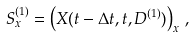Convert formula to latex. <formula><loc_0><loc_0><loc_500><loc_500>S ^ { ( 1 ) } _ { x } = \left ( X ( t - \Delta t , t , D ^ { ( 1 ) } ) \right ) _ { x } \, ,</formula> 